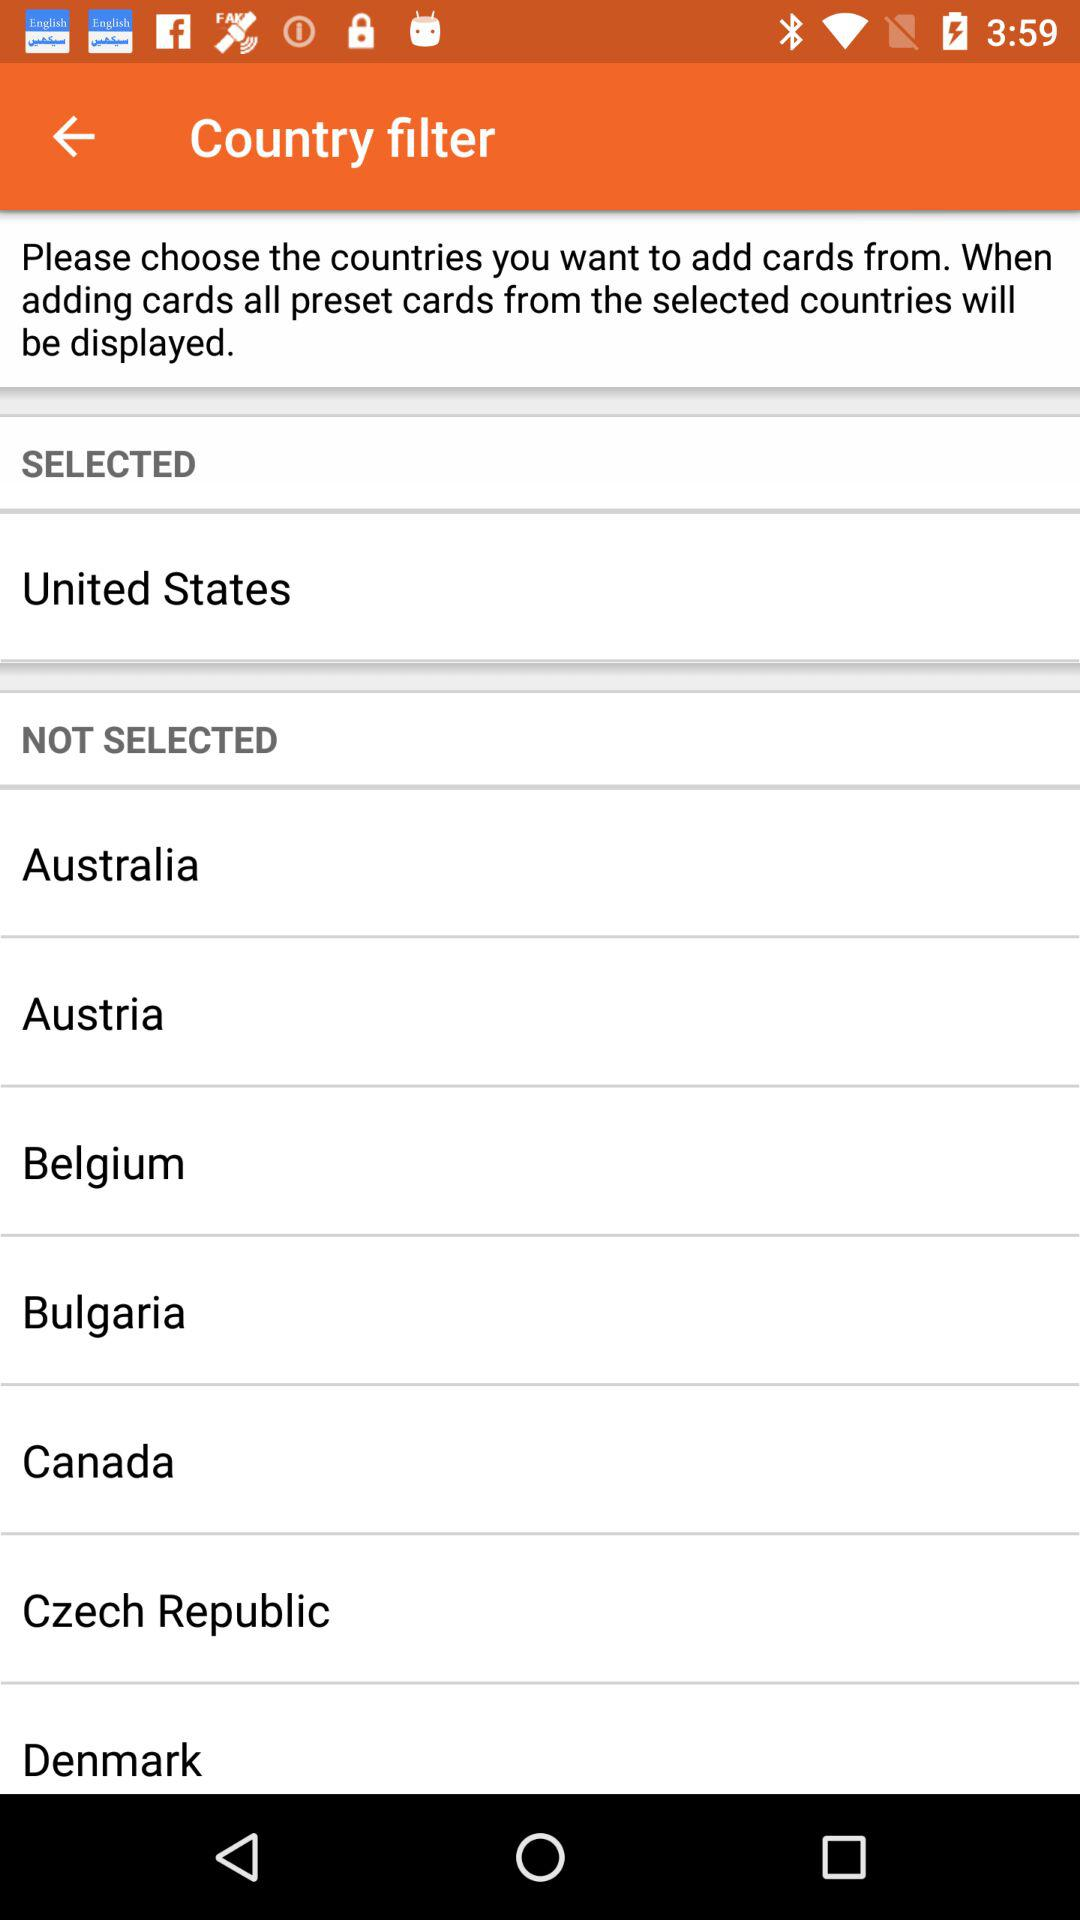What is the name of the selected country? The name of the selected country is the United States. 